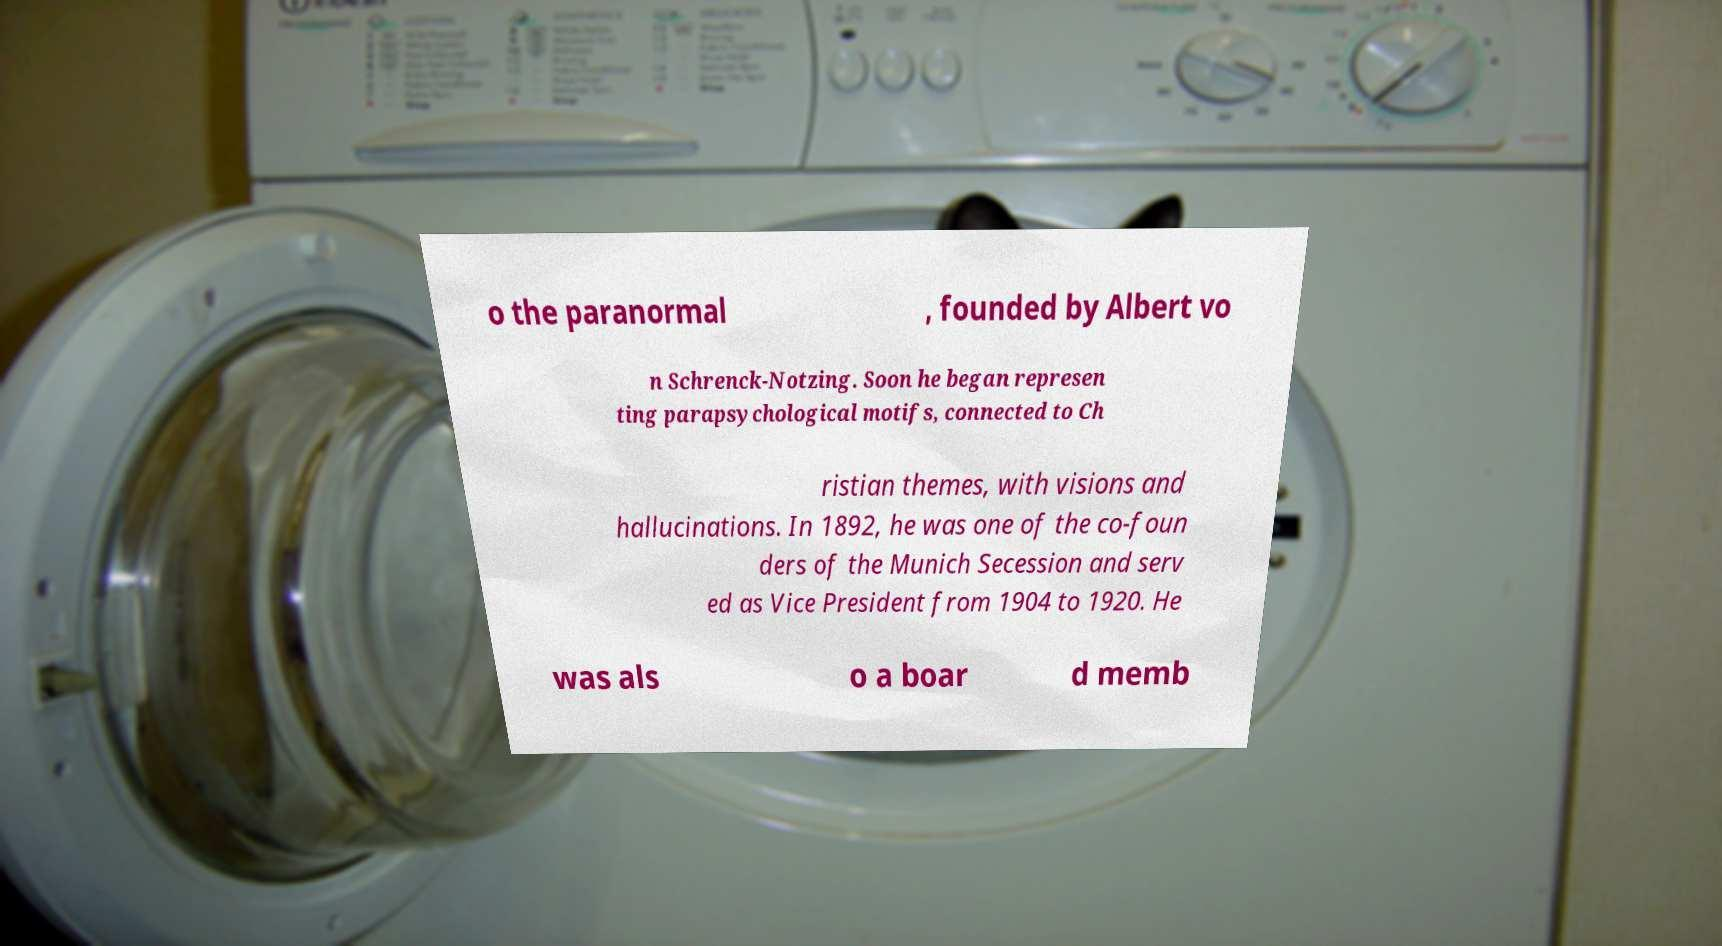For documentation purposes, I need the text within this image transcribed. Could you provide that? o the paranormal , founded by Albert vo n Schrenck-Notzing. Soon he began represen ting parapsychological motifs, connected to Ch ristian themes, with visions and hallucinations. In 1892, he was one of the co-foun ders of the Munich Secession and serv ed as Vice President from 1904 to 1920. He was als o a boar d memb 